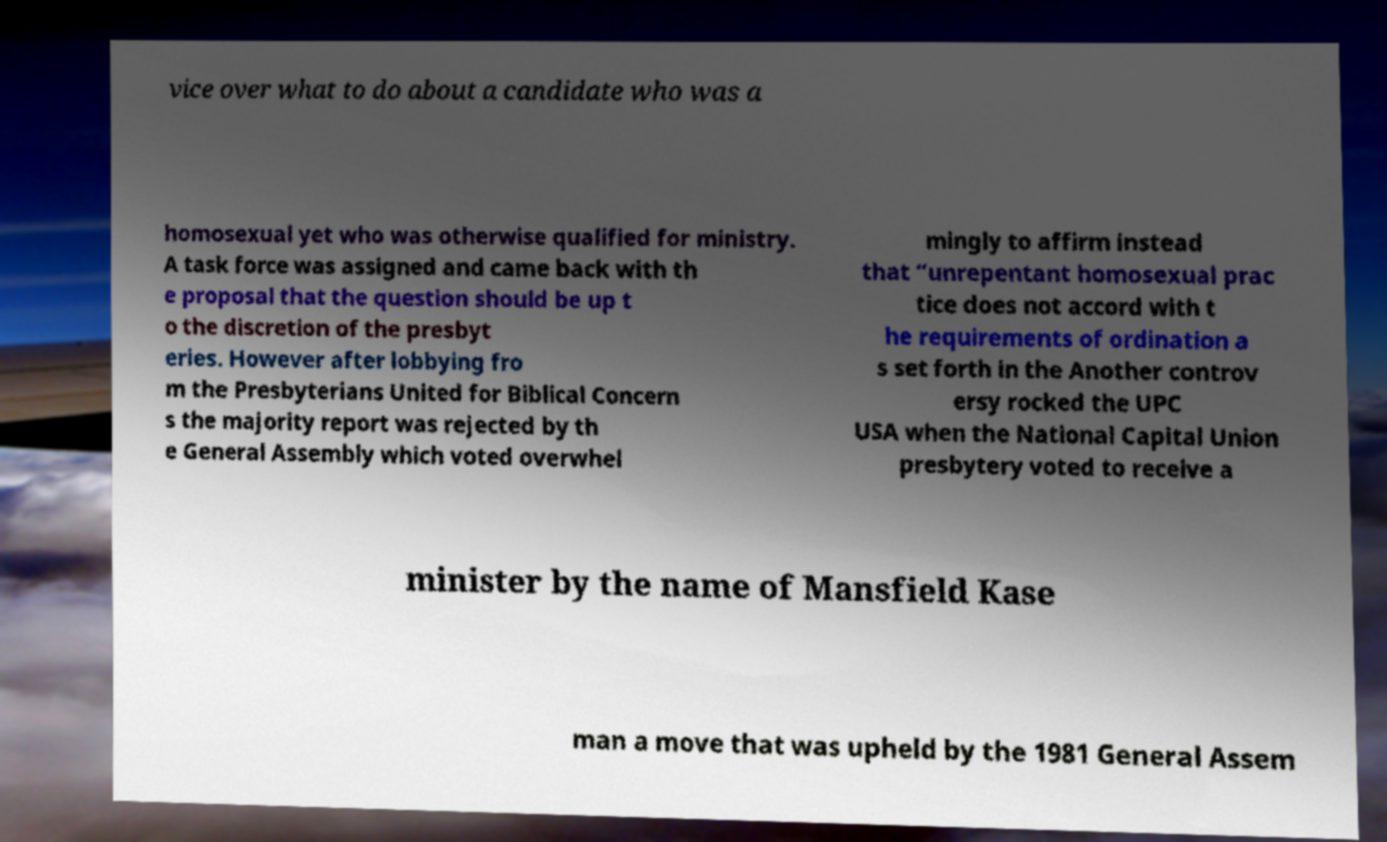For documentation purposes, I need the text within this image transcribed. Could you provide that? vice over what to do about a candidate who was a homosexual yet who was otherwise qualified for ministry. A task force was assigned and came back with th e proposal that the question should be up t o the discretion of the presbyt eries. However after lobbying fro m the Presbyterians United for Biblical Concern s the majority report was rejected by th e General Assembly which voted overwhel mingly to affirm instead that “unrepentant homosexual prac tice does not accord with t he requirements of ordination a s set forth in the Another controv ersy rocked the UPC USA when the National Capital Union presbytery voted to receive a minister by the name of Mansfield Kase man a move that was upheld by the 1981 General Assem 